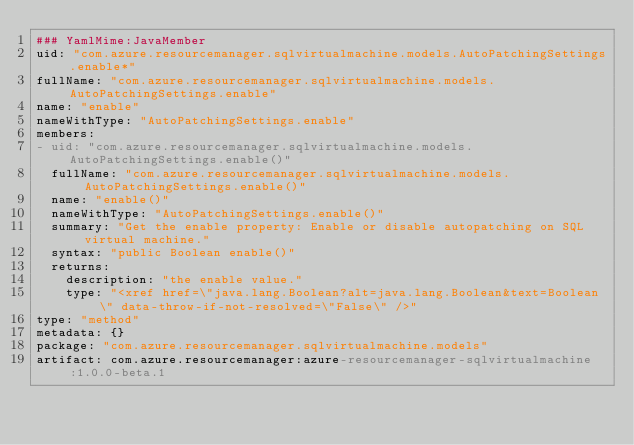<code> <loc_0><loc_0><loc_500><loc_500><_YAML_>### YamlMime:JavaMember
uid: "com.azure.resourcemanager.sqlvirtualmachine.models.AutoPatchingSettings.enable*"
fullName: "com.azure.resourcemanager.sqlvirtualmachine.models.AutoPatchingSettings.enable"
name: "enable"
nameWithType: "AutoPatchingSettings.enable"
members:
- uid: "com.azure.resourcemanager.sqlvirtualmachine.models.AutoPatchingSettings.enable()"
  fullName: "com.azure.resourcemanager.sqlvirtualmachine.models.AutoPatchingSettings.enable()"
  name: "enable()"
  nameWithType: "AutoPatchingSettings.enable()"
  summary: "Get the enable property: Enable or disable autopatching on SQL virtual machine."
  syntax: "public Boolean enable()"
  returns:
    description: "the enable value."
    type: "<xref href=\"java.lang.Boolean?alt=java.lang.Boolean&text=Boolean\" data-throw-if-not-resolved=\"False\" />"
type: "method"
metadata: {}
package: "com.azure.resourcemanager.sqlvirtualmachine.models"
artifact: com.azure.resourcemanager:azure-resourcemanager-sqlvirtualmachine:1.0.0-beta.1
</code> 